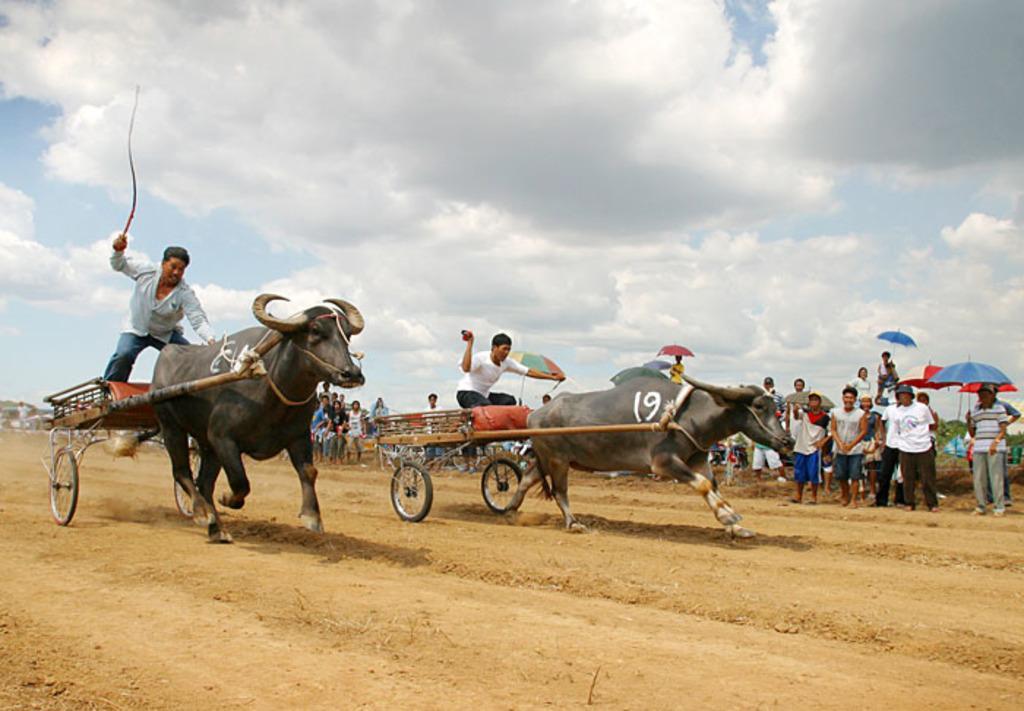Please provide a concise description of this image. In this image, we can see two persons on buffalo carts. There are some persons standing and wearing clothes in the middle of the image. There are some other persons on the right side of the image holding umbrellas with their hands. There are clouds in the sky. 